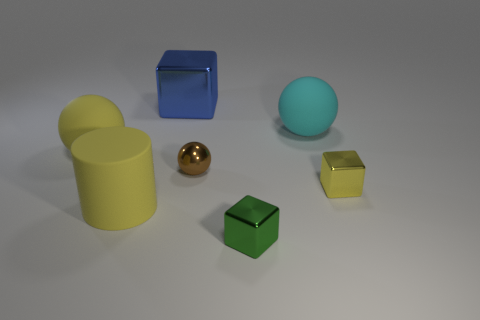Add 2 big matte cylinders. How many objects exist? 9 Subtract all blocks. How many objects are left? 4 Subtract all tiny green shiny blocks. Subtract all large spheres. How many objects are left? 4 Add 3 cyan rubber spheres. How many cyan rubber spheres are left? 4 Add 5 large yellow matte cylinders. How many large yellow matte cylinders exist? 6 Subtract 0 cyan cylinders. How many objects are left? 7 